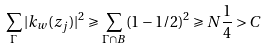<formula> <loc_0><loc_0><loc_500><loc_500>\sum _ { \Gamma } | k _ { w } ( z _ { j } ) | ^ { 2 } \geqslant \sum _ { \Gamma \cap B } ( 1 - 1 / 2 ) ^ { 2 } \geqslant N \frac { 1 } { 4 } > C</formula> 